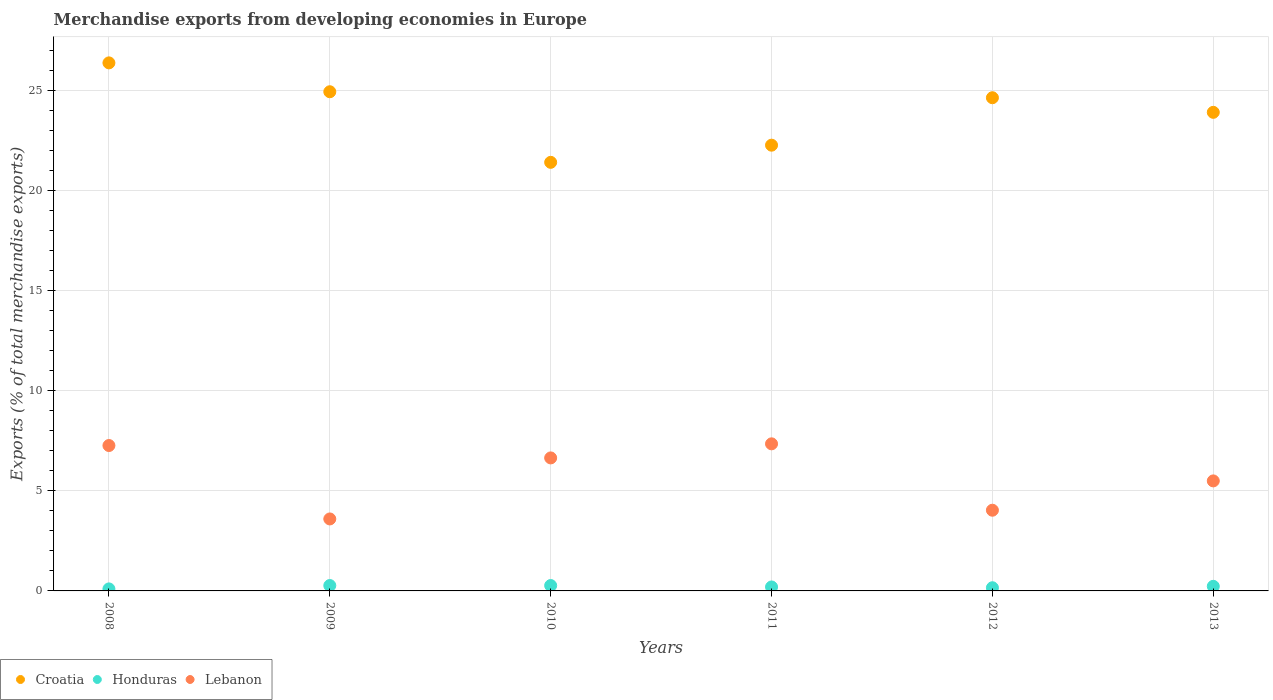How many different coloured dotlines are there?
Make the answer very short. 3. What is the percentage of total merchandise exports in Lebanon in 2009?
Offer a terse response. 3.59. Across all years, what is the maximum percentage of total merchandise exports in Honduras?
Provide a short and direct response. 0.27. Across all years, what is the minimum percentage of total merchandise exports in Honduras?
Your answer should be compact. 0.1. In which year was the percentage of total merchandise exports in Lebanon maximum?
Your answer should be very brief. 2011. In which year was the percentage of total merchandise exports in Lebanon minimum?
Ensure brevity in your answer.  2009. What is the total percentage of total merchandise exports in Croatia in the graph?
Give a very brief answer. 143.44. What is the difference between the percentage of total merchandise exports in Honduras in 2012 and that in 2013?
Ensure brevity in your answer.  -0.07. What is the difference between the percentage of total merchandise exports in Lebanon in 2013 and the percentage of total merchandise exports in Croatia in 2012?
Offer a very short reply. -19.13. What is the average percentage of total merchandise exports in Croatia per year?
Your answer should be compact. 23.91. In the year 2009, what is the difference between the percentage of total merchandise exports in Honduras and percentage of total merchandise exports in Croatia?
Offer a terse response. -24.65. In how many years, is the percentage of total merchandise exports in Croatia greater than 1 %?
Your answer should be compact. 6. What is the ratio of the percentage of total merchandise exports in Lebanon in 2011 to that in 2013?
Your response must be concise. 1.34. Is the percentage of total merchandise exports in Lebanon in 2010 less than that in 2011?
Provide a succinct answer. Yes. Is the difference between the percentage of total merchandise exports in Honduras in 2012 and 2013 greater than the difference between the percentage of total merchandise exports in Croatia in 2012 and 2013?
Your response must be concise. No. What is the difference between the highest and the second highest percentage of total merchandise exports in Honduras?
Offer a very short reply. 0. What is the difference between the highest and the lowest percentage of total merchandise exports in Croatia?
Offer a very short reply. 4.97. Is the sum of the percentage of total merchandise exports in Lebanon in 2008 and 2009 greater than the maximum percentage of total merchandise exports in Croatia across all years?
Offer a very short reply. No. Is it the case that in every year, the sum of the percentage of total merchandise exports in Croatia and percentage of total merchandise exports in Lebanon  is greater than the percentage of total merchandise exports in Honduras?
Your answer should be compact. Yes. Is the percentage of total merchandise exports in Honduras strictly greater than the percentage of total merchandise exports in Croatia over the years?
Offer a very short reply. No. Is the percentage of total merchandise exports in Lebanon strictly less than the percentage of total merchandise exports in Croatia over the years?
Offer a terse response. Yes. How many years are there in the graph?
Give a very brief answer. 6. Are the values on the major ticks of Y-axis written in scientific E-notation?
Your response must be concise. No. What is the title of the graph?
Ensure brevity in your answer.  Merchandise exports from developing economies in Europe. Does "Qatar" appear as one of the legend labels in the graph?
Offer a very short reply. No. What is the label or title of the Y-axis?
Offer a terse response. Exports (% of total merchandise exports). What is the Exports (% of total merchandise exports) in Croatia in 2008?
Your answer should be compact. 26.36. What is the Exports (% of total merchandise exports) of Honduras in 2008?
Ensure brevity in your answer.  0.1. What is the Exports (% of total merchandise exports) of Lebanon in 2008?
Your answer should be very brief. 7.26. What is the Exports (% of total merchandise exports) of Croatia in 2009?
Provide a succinct answer. 24.92. What is the Exports (% of total merchandise exports) in Honduras in 2009?
Give a very brief answer. 0.27. What is the Exports (% of total merchandise exports) in Lebanon in 2009?
Give a very brief answer. 3.59. What is the Exports (% of total merchandise exports) in Croatia in 2010?
Your response must be concise. 21.4. What is the Exports (% of total merchandise exports) of Honduras in 2010?
Keep it short and to the point. 0.27. What is the Exports (% of total merchandise exports) in Lebanon in 2010?
Your response must be concise. 6.64. What is the Exports (% of total merchandise exports) of Croatia in 2011?
Your answer should be compact. 22.25. What is the Exports (% of total merchandise exports) in Honduras in 2011?
Provide a short and direct response. 0.2. What is the Exports (% of total merchandise exports) of Lebanon in 2011?
Keep it short and to the point. 7.34. What is the Exports (% of total merchandise exports) in Croatia in 2012?
Offer a terse response. 24.62. What is the Exports (% of total merchandise exports) in Honduras in 2012?
Offer a very short reply. 0.16. What is the Exports (% of total merchandise exports) in Lebanon in 2012?
Give a very brief answer. 4.03. What is the Exports (% of total merchandise exports) of Croatia in 2013?
Your response must be concise. 23.89. What is the Exports (% of total merchandise exports) of Honduras in 2013?
Provide a succinct answer. 0.23. What is the Exports (% of total merchandise exports) in Lebanon in 2013?
Your answer should be compact. 5.49. Across all years, what is the maximum Exports (% of total merchandise exports) in Croatia?
Your answer should be very brief. 26.36. Across all years, what is the maximum Exports (% of total merchandise exports) in Honduras?
Your answer should be very brief. 0.27. Across all years, what is the maximum Exports (% of total merchandise exports) in Lebanon?
Your response must be concise. 7.34. Across all years, what is the minimum Exports (% of total merchandise exports) in Croatia?
Your response must be concise. 21.4. Across all years, what is the minimum Exports (% of total merchandise exports) in Honduras?
Keep it short and to the point. 0.1. Across all years, what is the minimum Exports (% of total merchandise exports) in Lebanon?
Give a very brief answer. 3.59. What is the total Exports (% of total merchandise exports) in Croatia in the graph?
Your response must be concise. 143.44. What is the total Exports (% of total merchandise exports) of Honduras in the graph?
Ensure brevity in your answer.  1.23. What is the total Exports (% of total merchandise exports) of Lebanon in the graph?
Provide a succinct answer. 34.36. What is the difference between the Exports (% of total merchandise exports) of Croatia in 2008 and that in 2009?
Your answer should be very brief. 1.44. What is the difference between the Exports (% of total merchandise exports) of Honduras in 2008 and that in 2009?
Make the answer very short. -0.17. What is the difference between the Exports (% of total merchandise exports) in Lebanon in 2008 and that in 2009?
Provide a short and direct response. 3.67. What is the difference between the Exports (% of total merchandise exports) of Croatia in 2008 and that in 2010?
Offer a terse response. 4.97. What is the difference between the Exports (% of total merchandise exports) in Honduras in 2008 and that in 2010?
Keep it short and to the point. -0.17. What is the difference between the Exports (% of total merchandise exports) of Lebanon in 2008 and that in 2010?
Give a very brief answer. 0.62. What is the difference between the Exports (% of total merchandise exports) of Croatia in 2008 and that in 2011?
Your response must be concise. 4.11. What is the difference between the Exports (% of total merchandise exports) of Honduras in 2008 and that in 2011?
Give a very brief answer. -0.1. What is the difference between the Exports (% of total merchandise exports) in Lebanon in 2008 and that in 2011?
Provide a succinct answer. -0.08. What is the difference between the Exports (% of total merchandise exports) in Croatia in 2008 and that in 2012?
Your answer should be very brief. 1.74. What is the difference between the Exports (% of total merchandise exports) of Honduras in 2008 and that in 2012?
Provide a succinct answer. -0.06. What is the difference between the Exports (% of total merchandise exports) of Lebanon in 2008 and that in 2012?
Ensure brevity in your answer.  3.23. What is the difference between the Exports (% of total merchandise exports) of Croatia in 2008 and that in 2013?
Make the answer very short. 2.47. What is the difference between the Exports (% of total merchandise exports) in Honduras in 2008 and that in 2013?
Your response must be concise. -0.13. What is the difference between the Exports (% of total merchandise exports) in Lebanon in 2008 and that in 2013?
Your answer should be compact. 1.77. What is the difference between the Exports (% of total merchandise exports) of Croatia in 2009 and that in 2010?
Keep it short and to the point. 3.52. What is the difference between the Exports (% of total merchandise exports) of Lebanon in 2009 and that in 2010?
Your answer should be compact. -3.05. What is the difference between the Exports (% of total merchandise exports) in Croatia in 2009 and that in 2011?
Provide a short and direct response. 2.67. What is the difference between the Exports (% of total merchandise exports) in Honduras in 2009 and that in 2011?
Keep it short and to the point. 0.07. What is the difference between the Exports (% of total merchandise exports) of Lebanon in 2009 and that in 2011?
Keep it short and to the point. -3.75. What is the difference between the Exports (% of total merchandise exports) in Croatia in 2009 and that in 2012?
Provide a short and direct response. 0.3. What is the difference between the Exports (% of total merchandise exports) of Honduras in 2009 and that in 2012?
Offer a terse response. 0.11. What is the difference between the Exports (% of total merchandise exports) of Lebanon in 2009 and that in 2012?
Provide a short and direct response. -0.44. What is the difference between the Exports (% of total merchandise exports) in Croatia in 2009 and that in 2013?
Offer a very short reply. 1.03. What is the difference between the Exports (% of total merchandise exports) in Honduras in 2009 and that in 2013?
Give a very brief answer. 0.04. What is the difference between the Exports (% of total merchandise exports) in Lebanon in 2009 and that in 2013?
Offer a very short reply. -1.9. What is the difference between the Exports (% of total merchandise exports) of Croatia in 2010 and that in 2011?
Make the answer very short. -0.86. What is the difference between the Exports (% of total merchandise exports) of Honduras in 2010 and that in 2011?
Provide a short and direct response. 0.07. What is the difference between the Exports (% of total merchandise exports) of Lebanon in 2010 and that in 2011?
Offer a terse response. -0.7. What is the difference between the Exports (% of total merchandise exports) in Croatia in 2010 and that in 2012?
Give a very brief answer. -3.23. What is the difference between the Exports (% of total merchandise exports) of Honduras in 2010 and that in 2012?
Your response must be concise. 0.11. What is the difference between the Exports (% of total merchandise exports) of Lebanon in 2010 and that in 2012?
Make the answer very short. 2.61. What is the difference between the Exports (% of total merchandise exports) of Croatia in 2010 and that in 2013?
Your answer should be very brief. -2.5. What is the difference between the Exports (% of total merchandise exports) of Honduras in 2010 and that in 2013?
Provide a short and direct response. 0.04. What is the difference between the Exports (% of total merchandise exports) of Lebanon in 2010 and that in 2013?
Give a very brief answer. 1.15. What is the difference between the Exports (% of total merchandise exports) in Croatia in 2011 and that in 2012?
Your answer should be compact. -2.37. What is the difference between the Exports (% of total merchandise exports) in Honduras in 2011 and that in 2012?
Provide a short and direct response. 0.04. What is the difference between the Exports (% of total merchandise exports) in Lebanon in 2011 and that in 2012?
Your answer should be very brief. 3.31. What is the difference between the Exports (% of total merchandise exports) in Croatia in 2011 and that in 2013?
Your response must be concise. -1.64. What is the difference between the Exports (% of total merchandise exports) of Honduras in 2011 and that in 2013?
Offer a terse response. -0.03. What is the difference between the Exports (% of total merchandise exports) of Lebanon in 2011 and that in 2013?
Your response must be concise. 1.85. What is the difference between the Exports (% of total merchandise exports) of Croatia in 2012 and that in 2013?
Give a very brief answer. 0.73. What is the difference between the Exports (% of total merchandise exports) of Honduras in 2012 and that in 2013?
Make the answer very short. -0.07. What is the difference between the Exports (% of total merchandise exports) in Lebanon in 2012 and that in 2013?
Your answer should be compact. -1.46. What is the difference between the Exports (% of total merchandise exports) in Croatia in 2008 and the Exports (% of total merchandise exports) in Honduras in 2009?
Give a very brief answer. 26.09. What is the difference between the Exports (% of total merchandise exports) of Croatia in 2008 and the Exports (% of total merchandise exports) of Lebanon in 2009?
Provide a succinct answer. 22.77. What is the difference between the Exports (% of total merchandise exports) of Honduras in 2008 and the Exports (% of total merchandise exports) of Lebanon in 2009?
Provide a succinct answer. -3.49. What is the difference between the Exports (% of total merchandise exports) of Croatia in 2008 and the Exports (% of total merchandise exports) of Honduras in 2010?
Your answer should be compact. 26.09. What is the difference between the Exports (% of total merchandise exports) in Croatia in 2008 and the Exports (% of total merchandise exports) in Lebanon in 2010?
Provide a short and direct response. 19.72. What is the difference between the Exports (% of total merchandise exports) in Honduras in 2008 and the Exports (% of total merchandise exports) in Lebanon in 2010?
Provide a short and direct response. -6.54. What is the difference between the Exports (% of total merchandise exports) of Croatia in 2008 and the Exports (% of total merchandise exports) of Honduras in 2011?
Keep it short and to the point. 26.16. What is the difference between the Exports (% of total merchandise exports) in Croatia in 2008 and the Exports (% of total merchandise exports) in Lebanon in 2011?
Your answer should be very brief. 19.02. What is the difference between the Exports (% of total merchandise exports) in Honduras in 2008 and the Exports (% of total merchandise exports) in Lebanon in 2011?
Your answer should be compact. -7.24. What is the difference between the Exports (% of total merchandise exports) of Croatia in 2008 and the Exports (% of total merchandise exports) of Honduras in 2012?
Keep it short and to the point. 26.2. What is the difference between the Exports (% of total merchandise exports) in Croatia in 2008 and the Exports (% of total merchandise exports) in Lebanon in 2012?
Your answer should be very brief. 22.33. What is the difference between the Exports (% of total merchandise exports) in Honduras in 2008 and the Exports (% of total merchandise exports) in Lebanon in 2012?
Provide a short and direct response. -3.93. What is the difference between the Exports (% of total merchandise exports) in Croatia in 2008 and the Exports (% of total merchandise exports) in Honduras in 2013?
Keep it short and to the point. 26.13. What is the difference between the Exports (% of total merchandise exports) of Croatia in 2008 and the Exports (% of total merchandise exports) of Lebanon in 2013?
Give a very brief answer. 20.87. What is the difference between the Exports (% of total merchandise exports) of Honduras in 2008 and the Exports (% of total merchandise exports) of Lebanon in 2013?
Your response must be concise. -5.39. What is the difference between the Exports (% of total merchandise exports) of Croatia in 2009 and the Exports (% of total merchandise exports) of Honduras in 2010?
Provide a short and direct response. 24.65. What is the difference between the Exports (% of total merchandise exports) of Croatia in 2009 and the Exports (% of total merchandise exports) of Lebanon in 2010?
Ensure brevity in your answer.  18.28. What is the difference between the Exports (% of total merchandise exports) in Honduras in 2009 and the Exports (% of total merchandise exports) in Lebanon in 2010?
Ensure brevity in your answer.  -6.37. What is the difference between the Exports (% of total merchandise exports) of Croatia in 2009 and the Exports (% of total merchandise exports) of Honduras in 2011?
Your answer should be very brief. 24.72. What is the difference between the Exports (% of total merchandise exports) of Croatia in 2009 and the Exports (% of total merchandise exports) of Lebanon in 2011?
Give a very brief answer. 17.58. What is the difference between the Exports (% of total merchandise exports) in Honduras in 2009 and the Exports (% of total merchandise exports) in Lebanon in 2011?
Your response must be concise. -7.07. What is the difference between the Exports (% of total merchandise exports) of Croatia in 2009 and the Exports (% of total merchandise exports) of Honduras in 2012?
Make the answer very short. 24.76. What is the difference between the Exports (% of total merchandise exports) of Croatia in 2009 and the Exports (% of total merchandise exports) of Lebanon in 2012?
Ensure brevity in your answer.  20.89. What is the difference between the Exports (% of total merchandise exports) in Honduras in 2009 and the Exports (% of total merchandise exports) in Lebanon in 2012?
Your answer should be very brief. -3.76. What is the difference between the Exports (% of total merchandise exports) of Croatia in 2009 and the Exports (% of total merchandise exports) of Honduras in 2013?
Give a very brief answer. 24.69. What is the difference between the Exports (% of total merchandise exports) of Croatia in 2009 and the Exports (% of total merchandise exports) of Lebanon in 2013?
Your answer should be very brief. 19.43. What is the difference between the Exports (% of total merchandise exports) of Honduras in 2009 and the Exports (% of total merchandise exports) of Lebanon in 2013?
Ensure brevity in your answer.  -5.22. What is the difference between the Exports (% of total merchandise exports) in Croatia in 2010 and the Exports (% of total merchandise exports) in Honduras in 2011?
Provide a succinct answer. 21.2. What is the difference between the Exports (% of total merchandise exports) in Croatia in 2010 and the Exports (% of total merchandise exports) in Lebanon in 2011?
Make the answer very short. 14.05. What is the difference between the Exports (% of total merchandise exports) in Honduras in 2010 and the Exports (% of total merchandise exports) in Lebanon in 2011?
Make the answer very short. -7.07. What is the difference between the Exports (% of total merchandise exports) in Croatia in 2010 and the Exports (% of total merchandise exports) in Honduras in 2012?
Make the answer very short. 21.24. What is the difference between the Exports (% of total merchandise exports) in Croatia in 2010 and the Exports (% of total merchandise exports) in Lebanon in 2012?
Offer a very short reply. 17.37. What is the difference between the Exports (% of total merchandise exports) of Honduras in 2010 and the Exports (% of total merchandise exports) of Lebanon in 2012?
Give a very brief answer. -3.76. What is the difference between the Exports (% of total merchandise exports) in Croatia in 2010 and the Exports (% of total merchandise exports) in Honduras in 2013?
Ensure brevity in your answer.  21.17. What is the difference between the Exports (% of total merchandise exports) in Croatia in 2010 and the Exports (% of total merchandise exports) in Lebanon in 2013?
Your response must be concise. 15.9. What is the difference between the Exports (% of total merchandise exports) of Honduras in 2010 and the Exports (% of total merchandise exports) of Lebanon in 2013?
Give a very brief answer. -5.22. What is the difference between the Exports (% of total merchandise exports) of Croatia in 2011 and the Exports (% of total merchandise exports) of Honduras in 2012?
Ensure brevity in your answer.  22.09. What is the difference between the Exports (% of total merchandise exports) of Croatia in 2011 and the Exports (% of total merchandise exports) of Lebanon in 2012?
Your answer should be compact. 18.22. What is the difference between the Exports (% of total merchandise exports) in Honduras in 2011 and the Exports (% of total merchandise exports) in Lebanon in 2012?
Offer a very short reply. -3.83. What is the difference between the Exports (% of total merchandise exports) of Croatia in 2011 and the Exports (% of total merchandise exports) of Honduras in 2013?
Your response must be concise. 22.02. What is the difference between the Exports (% of total merchandise exports) in Croatia in 2011 and the Exports (% of total merchandise exports) in Lebanon in 2013?
Your response must be concise. 16.76. What is the difference between the Exports (% of total merchandise exports) of Honduras in 2011 and the Exports (% of total merchandise exports) of Lebanon in 2013?
Give a very brief answer. -5.29. What is the difference between the Exports (% of total merchandise exports) of Croatia in 2012 and the Exports (% of total merchandise exports) of Honduras in 2013?
Give a very brief answer. 24.39. What is the difference between the Exports (% of total merchandise exports) of Croatia in 2012 and the Exports (% of total merchandise exports) of Lebanon in 2013?
Provide a succinct answer. 19.13. What is the difference between the Exports (% of total merchandise exports) in Honduras in 2012 and the Exports (% of total merchandise exports) in Lebanon in 2013?
Ensure brevity in your answer.  -5.33. What is the average Exports (% of total merchandise exports) in Croatia per year?
Ensure brevity in your answer.  23.91. What is the average Exports (% of total merchandise exports) in Honduras per year?
Your response must be concise. 0.2. What is the average Exports (% of total merchandise exports) in Lebanon per year?
Give a very brief answer. 5.73. In the year 2008, what is the difference between the Exports (% of total merchandise exports) of Croatia and Exports (% of total merchandise exports) of Honduras?
Provide a succinct answer. 26.26. In the year 2008, what is the difference between the Exports (% of total merchandise exports) of Croatia and Exports (% of total merchandise exports) of Lebanon?
Provide a short and direct response. 19.1. In the year 2008, what is the difference between the Exports (% of total merchandise exports) of Honduras and Exports (% of total merchandise exports) of Lebanon?
Offer a terse response. -7.16. In the year 2009, what is the difference between the Exports (% of total merchandise exports) of Croatia and Exports (% of total merchandise exports) of Honduras?
Your answer should be very brief. 24.65. In the year 2009, what is the difference between the Exports (% of total merchandise exports) of Croatia and Exports (% of total merchandise exports) of Lebanon?
Your answer should be very brief. 21.33. In the year 2009, what is the difference between the Exports (% of total merchandise exports) of Honduras and Exports (% of total merchandise exports) of Lebanon?
Your answer should be very brief. -3.32. In the year 2010, what is the difference between the Exports (% of total merchandise exports) in Croatia and Exports (% of total merchandise exports) in Honduras?
Offer a very short reply. 21.13. In the year 2010, what is the difference between the Exports (% of total merchandise exports) of Croatia and Exports (% of total merchandise exports) of Lebanon?
Provide a succinct answer. 14.76. In the year 2010, what is the difference between the Exports (% of total merchandise exports) of Honduras and Exports (% of total merchandise exports) of Lebanon?
Provide a succinct answer. -6.37. In the year 2011, what is the difference between the Exports (% of total merchandise exports) of Croatia and Exports (% of total merchandise exports) of Honduras?
Give a very brief answer. 22.05. In the year 2011, what is the difference between the Exports (% of total merchandise exports) of Croatia and Exports (% of total merchandise exports) of Lebanon?
Provide a succinct answer. 14.91. In the year 2011, what is the difference between the Exports (% of total merchandise exports) of Honduras and Exports (% of total merchandise exports) of Lebanon?
Offer a terse response. -7.15. In the year 2012, what is the difference between the Exports (% of total merchandise exports) of Croatia and Exports (% of total merchandise exports) of Honduras?
Offer a terse response. 24.46. In the year 2012, what is the difference between the Exports (% of total merchandise exports) in Croatia and Exports (% of total merchandise exports) in Lebanon?
Provide a succinct answer. 20.59. In the year 2012, what is the difference between the Exports (% of total merchandise exports) of Honduras and Exports (% of total merchandise exports) of Lebanon?
Provide a succinct answer. -3.87. In the year 2013, what is the difference between the Exports (% of total merchandise exports) in Croatia and Exports (% of total merchandise exports) in Honduras?
Give a very brief answer. 23.66. In the year 2013, what is the difference between the Exports (% of total merchandise exports) in Croatia and Exports (% of total merchandise exports) in Lebanon?
Keep it short and to the point. 18.4. In the year 2013, what is the difference between the Exports (% of total merchandise exports) in Honduras and Exports (% of total merchandise exports) in Lebanon?
Provide a succinct answer. -5.26. What is the ratio of the Exports (% of total merchandise exports) in Croatia in 2008 to that in 2009?
Offer a very short reply. 1.06. What is the ratio of the Exports (% of total merchandise exports) of Honduras in 2008 to that in 2009?
Offer a terse response. 0.37. What is the ratio of the Exports (% of total merchandise exports) in Lebanon in 2008 to that in 2009?
Your answer should be very brief. 2.02. What is the ratio of the Exports (% of total merchandise exports) in Croatia in 2008 to that in 2010?
Make the answer very short. 1.23. What is the ratio of the Exports (% of total merchandise exports) of Honduras in 2008 to that in 2010?
Give a very brief answer. 0.37. What is the ratio of the Exports (% of total merchandise exports) of Lebanon in 2008 to that in 2010?
Offer a terse response. 1.09. What is the ratio of the Exports (% of total merchandise exports) of Croatia in 2008 to that in 2011?
Offer a terse response. 1.18. What is the ratio of the Exports (% of total merchandise exports) of Honduras in 2008 to that in 2011?
Provide a succinct answer. 0.51. What is the ratio of the Exports (% of total merchandise exports) of Lebanon in 2008 to that in 2011?
Provide a short and direct response. 0.99. What is the ratio of the Exports (% of total merchandise exports) of Croatia in 2008 to that in 2012?
Provide a short and direct response. 1.07. What is the ratio of the Exports (% of total merchandise exports) in Honduras in 2008 to that in 2012?
Provide a succinct answer. 0.63. What is the ratio of the Exports (% of total merchandise exports) of Lebanon in 2008 to that in 2012?
Offer a terse response. 1.8. What is the ratio of the Exports (% of total merchandise exports) in Croatia in 2008 to that in 2013?
Provide a succinct answer. 1.1. What is the ratio of the Exports (% of total merchandise exports) in Honduras in 2008 to that in 2013?
Your answer should be compact. 0.44. What is the ratio of the Exports (% of total merchandise exports) of Lebanon in 2008 to that in 2013?
Offer a very short reply. 1.32. What is the ratio of the Exports (% of total merchandise exports) of Croatia in 2009 to that in 2010?
Provide a short and direct response. 1.16. What is the ratio of the Exports (% of total merchandise exports) of Honduras in 2009 to that in 2010?
Offer a terse response. 1. What is the ratio of the Exports (% of total merchandise exports) in Lebanon in 2009 to that in 2010?
Ensure brevity in your answer.  0.54. What is the ratio of the Exports (% of total merchandise exports) in Croatia in 2009 to that in 2011?
Your response must be concise. 1.12. What is the ratio of the Exports (% of total merchandise exports) in Honduras in 2009 to that in 2011?
Your answer should be very brief. 1.36. What is the ratio of the Exports (% of total merchandise exports) in Lebanon in 2009 to that in 2011?
Offer a terse response. 0.49. What is the ratio of the Exports (% of total merchandise exports) of Croatia in 2009 to that in 2012?
Your response must be concise. 1.01. What is the ratio of the Exports (% of total merchandise exports) of Honduras in 2009 to that in 2012?
Make the answer very short. 1.69. What is the ratio of the Exports (% of total merchandise exports) in Lebanon in 2009 to that in 2012?
Your response must be concise. 0.89. What is the ratio of the Exports (% of total merchandise exports) in Croatia in 2009 to that in 2013?
Make the answer very short. 1.04. What is the ratio of the Exports (% of total merchandise exports) of Honduras in 2009 to that in 2013?
Your answer should be very brief. 1.17. What is the ratio of the Exports (% of total merchandise exports) of Lebanon in 2009 to that in 2013?
Make the answer very short. 0.65. What is the ratio of the Exports (% of total merchandise exports) of Croatia in 2010 to that in 2011?
Your answer should be very brief. 0.96. What is the ratio of the Exports (% of total merchandise exports) in Honduras in 2010 to that in 2011?
Offer a terse response. 1.36. What is the ratio of the Exports (% of total merchandise exports) in Lebanon in 2010 to that in 2011?
Offer a very short reply. 0.9. What is the ratio of the Exports (% of total merchandise exports) of Croatia in 2010 to that in 2012?
Provide a succinct answer. 0.87. What is the ratio of the Exports (% of total merchandise exports) in Honduras in 2010 to that in 2012?
Offer a terse response. 1.69. What is the ratio of the Exports (% of total merchandise exports) of Lebanon in 2010 to that in 2012?
Ensure brevity in your answer.  1.65. What is the ratio of the Exports (% of total merchandise exports) in Croatia in 2010 to that in 2013?
Ensure brevity in your answer.  0.9. What is the ratio of the Exports (% of total merchandise exports) of Honduras in 2010 to that in 2013?
Offer a terse response. 1.17. What is the ratio of the Exports (% of total merchandise exports) of Lebanon in 2010 to that in 2013?
Your answer should be compact. 1.21. What is the ratio of the Exports (% of total merchandise exports) of Croatia in 2011 to that in 2012?
Give a very brief answer. 0.9. What is the ratio of the Exports (% of total merchandise exports) of Honduras in 2011 to that in 2012?
Your response must be concise. 1.25. What is the ratio of the Exports (% of total merchandise exports) of Lebanon in 2011 to that in 2012?
Ensure brevity in your answer.  1.82. What is the ratio of the Exports (% of total merchandise exports) in Croatia in 2011 to that in 2013?
Ensure brevity in your answer.  0.93. What is the ratio of the Exports (% of total merchandise exports) of Honduras in 2011 to that in 2013?
Provide a short and direct response. 0.86. What is the ratio of the Exports (% of total merchandise exports) of Lebanon in 2011 to that in 2013?
Your response must be concise. 1.34. What is the ratio of the Exports (% of total merchandise exports) of Croatia in 2012 to that in 2013?
Offer a terse response. 1.03. What is the ratio of the Exports (% of total merchandise exports) in Honduras in 2012 to that in 2013?
Your answer should be very brief. 0.69. What is the ratio of the Exports (% of total merchandise exports) in Lebanon in 2012 to that in 2013?
Your response must be concise. 0.73. What is the difference between the highest and the second highest Exports (% of total merchandise exports) of Croatia?
Provide a short and direct response. 1.44. What is the difference between the highest and the second highest Exports (% of total merchandise exports) of Honduras?
Keep it short and to the point. 0. What is the difference between the highest and the second highest Exports (% of total merchandise exports) in Lebanon?
Offer a terse response. 0.08. What is the difference between the highest and the lowest Exports (% of total merchandise exports) of Croatia?
Ensure brevity in your answer.  4.97. What is the difference between the highest and the lowest Exports (% of total merchandise exports) in Honduras?
Make the answer very short. 0.17. What is the difference between the highest and the lowest Exports (% of total merchandise exports) of Lebanon?
Provide a short and direct response. 3.75. 